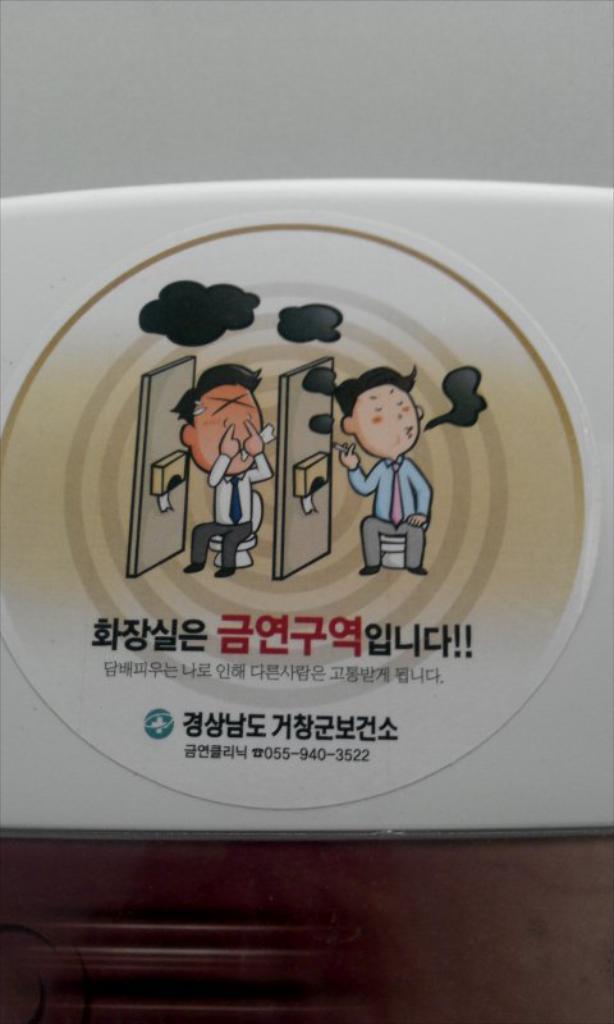Describe this image in one or two sentences. In this picture we can see a sticker on a white object and on the sticker there are two persons sitting on toilet seats. 